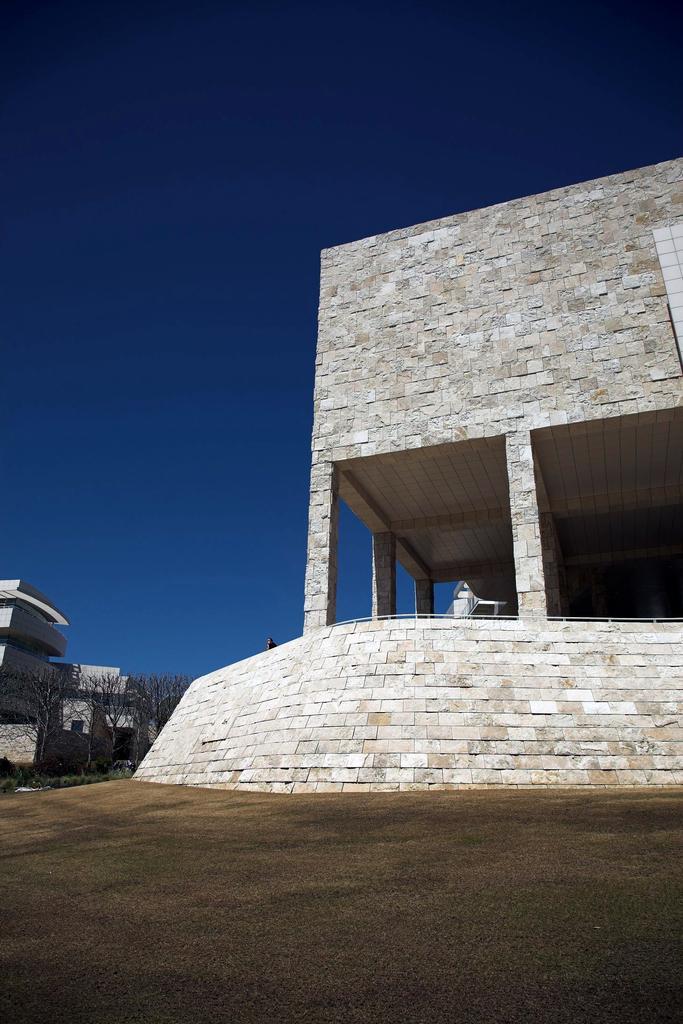Please provide a concise description of this image. In this image there is a building, in building there is a person, table, at the top there is the sky, on the left side there are buildings and trees visible. 